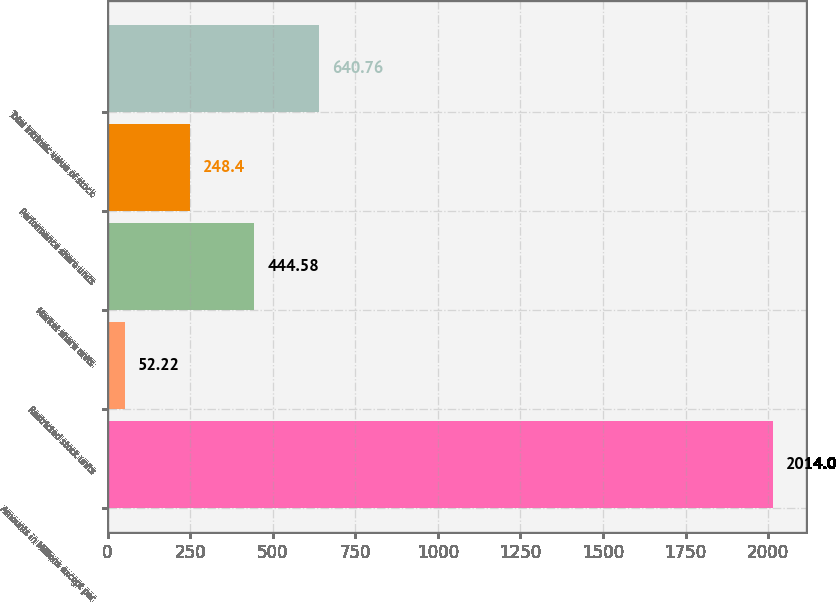Convert chart to OTSL. <chart><loc_0><loc_0><loc_500><loc_500><bar_chart><fcel>Amounts in Millions except per<fcel>Restricted stock units<fcel>Market share units<fcel>Performance share units<fcel>Total intrinsic value of stock<nl><fcel>2014<fcel>52.22<fcel>444.58<fcel>248.4<fcel>640.76<nl></chart> 